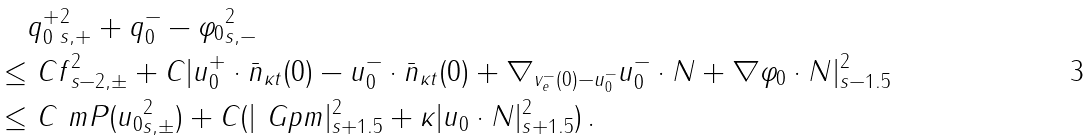<formula> <loc_0><loc_0><loc_500><loc_500>& \| q _ { 0 } ^ { + } \| ^ { 2 } _ { s , + } + \| q _ { 0 } ^ { - } - \varphi _ { 0 } \| ^ { 2 } _ { s , - } \\ \leq & \ C \| f \| ^ { 2 } _ { s - 2 , \pm } + C | u _ { 0 } ^ { + } \cdot \bar { n } _ { \kappa t } ( 0 ) - u _ { 0 } ^ { - } \cdot \bar { n } _ { \kappa t } ( 0 ) + \nabla _ { v _ { e } ^ { - } ( 0 ) - u _ { 0 } ^ { - } } u _ { 0 } ^ { - } \cdot N + \nabla \varphi _ { 0 } \cdot N | ^ { 2 } _ { s - 1 . 5 } \\ \leq & \ C \ m P ( \| u _ { 0 } \| ^ { 2 } _ { s , \pm } ) + C ( | \ G p m | ^ { 2 } _ { s + 1 . 5 } + \kappa | u _ { 0 } \cdot N | ^ { 2 } _ { s + 1 . 5 } ) \, .</formula> 